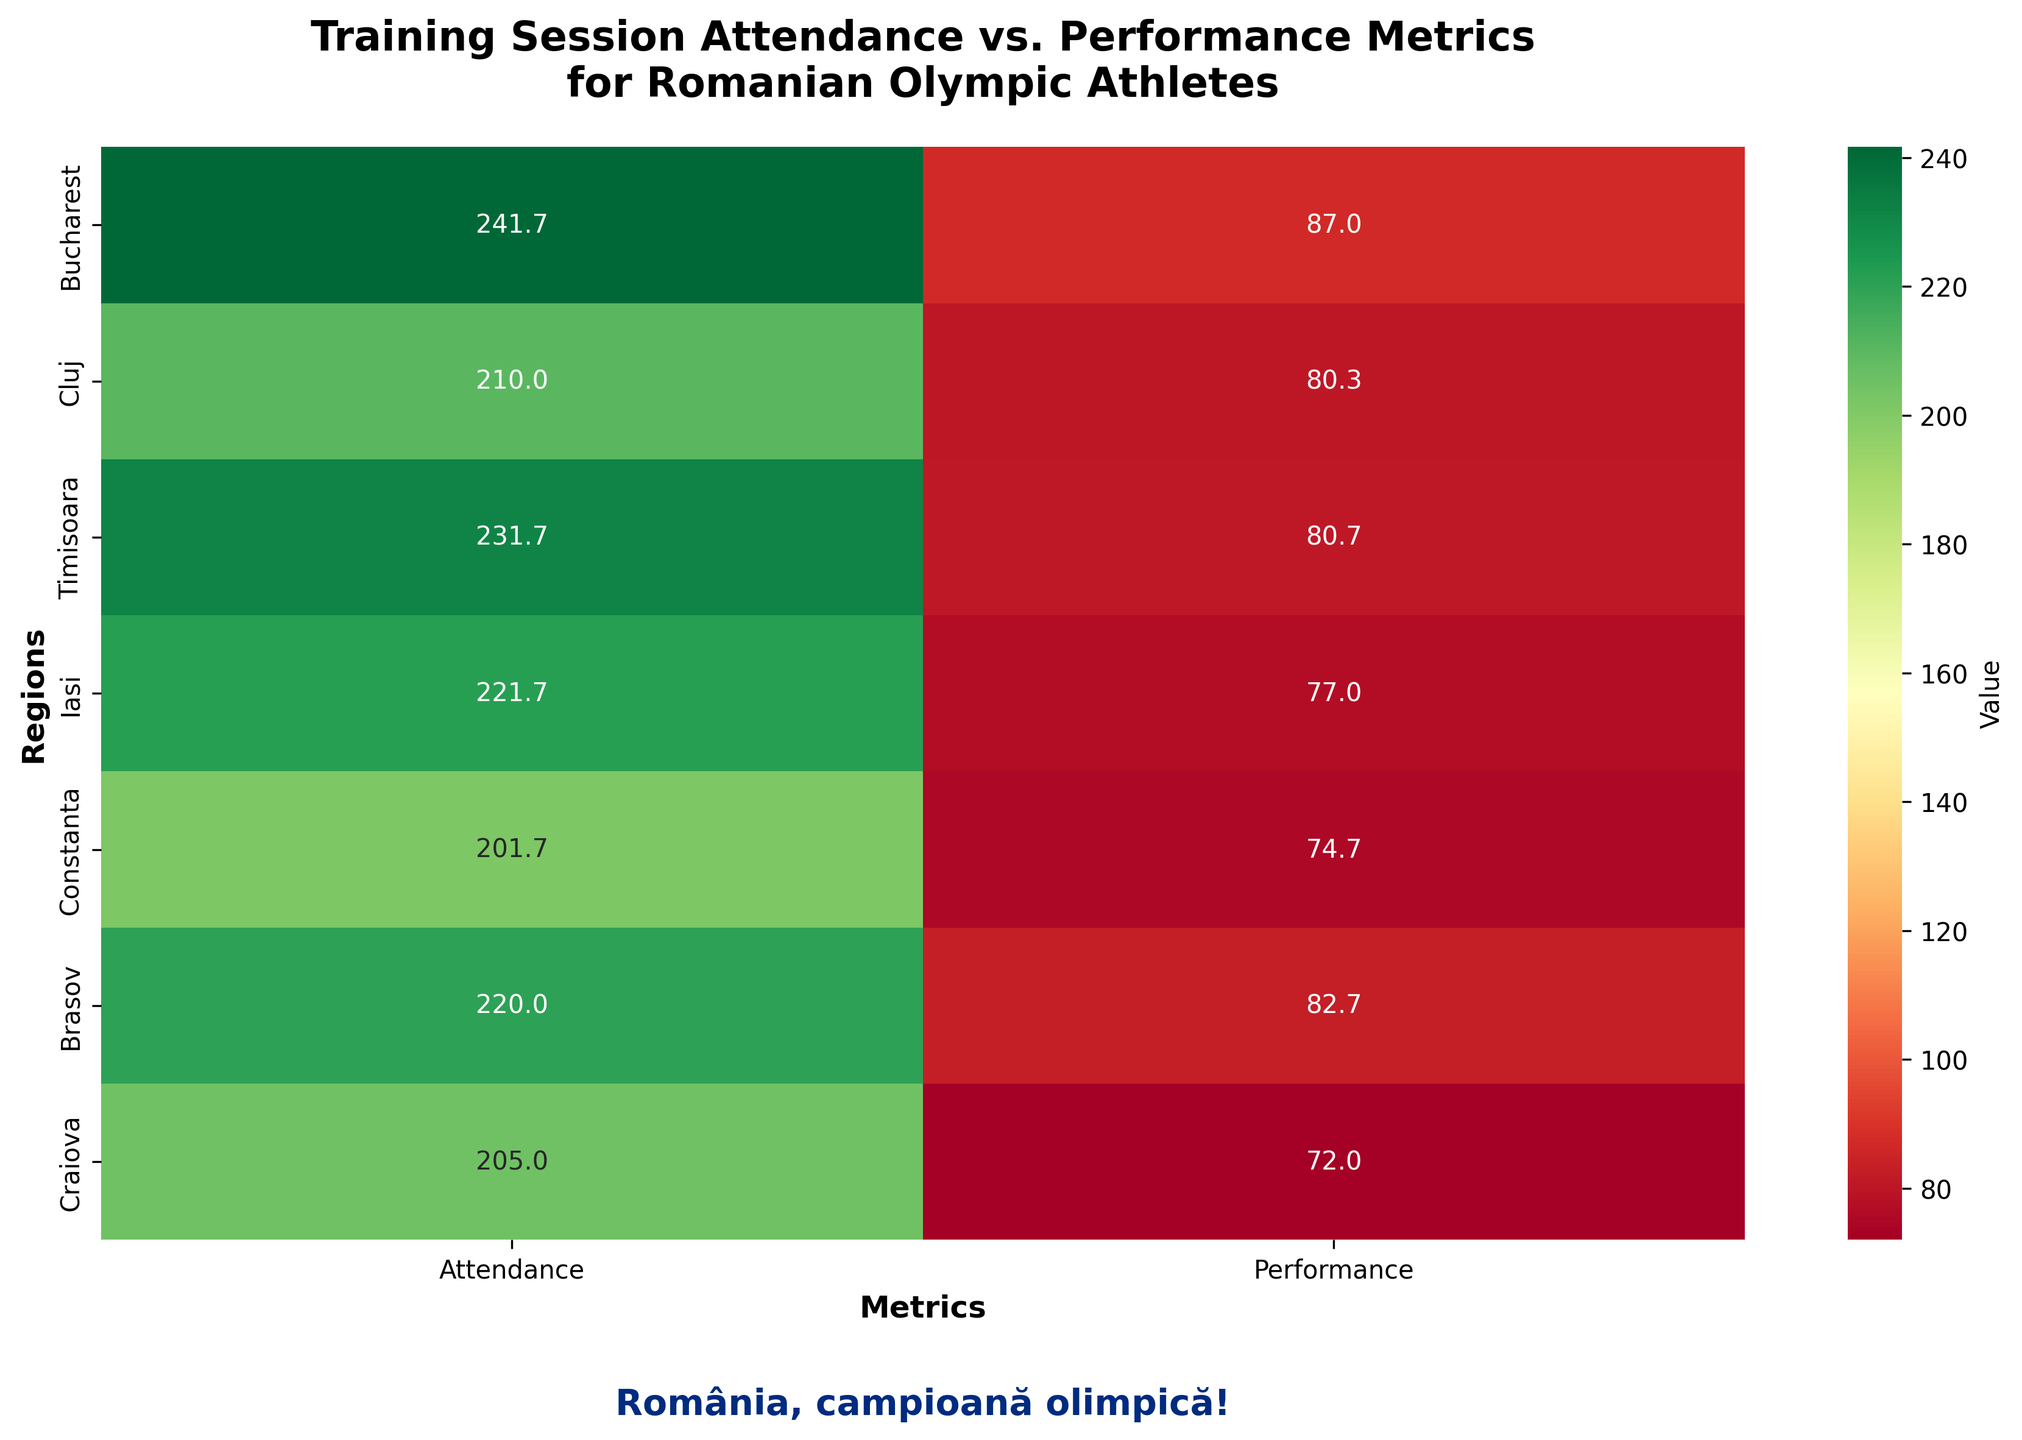What are the regions included in the heatmap? The regions can be identified from the heatmap's y-axis labels, which include Bucharest, Cluj, Timisoara, Iasi, Constanta, Brasov, and Craiova.
Answer: Bucharest, Cluj, Timisoara, Iasi, Constanta, Brasov, Craiova Which region has the highest average training session attendance? By observing the heatmap values for attendance, Bucharest shows the highest average training hours.
Answer: Bucharest How do the average performance scores compare between Bucharest and Cluj? By comparing the performance scores in the heatmap, Bucharest has a higher average performance score than Cluj, showing 87 compared to 80.3.
Answer: Bucharest has a higher average performance score What is the average performance metric for Timisoara athletes? The average performance score for Timisoara athletes, as per the heatmap, is 80.7.
Answer: 80.7 Which region has the lowest average performance metric and what is the value? From the heatmap, Craiova has the lowest average performance score, which is 72.
Answer: Craiova, 72 Compare the average training session attendance between Constanta and Craiova. Which one is higher? The heatmap shows Constanta with an average attendance of 201.7, whereas Craiova has 205. Therefore, Craiova's average training session attendance is higher.
Answer: Craiova Which metrics are shown on the x-axis of the heatmap? The metrics are labeled on the x-axis as Attendance and Performance.
Answer: Attendance and Performance What is the difference in average performance scores between Iasi and Brasov? Iasi has an average performance score of 77, and Brasov has 82.7. The difference is 82.7 - 77 = 5.7.
Answer: 5.7 What is the total number of regions represented in the heatmap? By counting the y-axis labels, we see there are seven regions represented.
Answer: 7 Would you say that regions with higher training session attendance also have higher performance metrics on average? Observing the heatmap, regions with higher training session attendance such as Bucharest and Brasov tend to have higher performance metrics, supporting a correlation.
Answer: Yes 